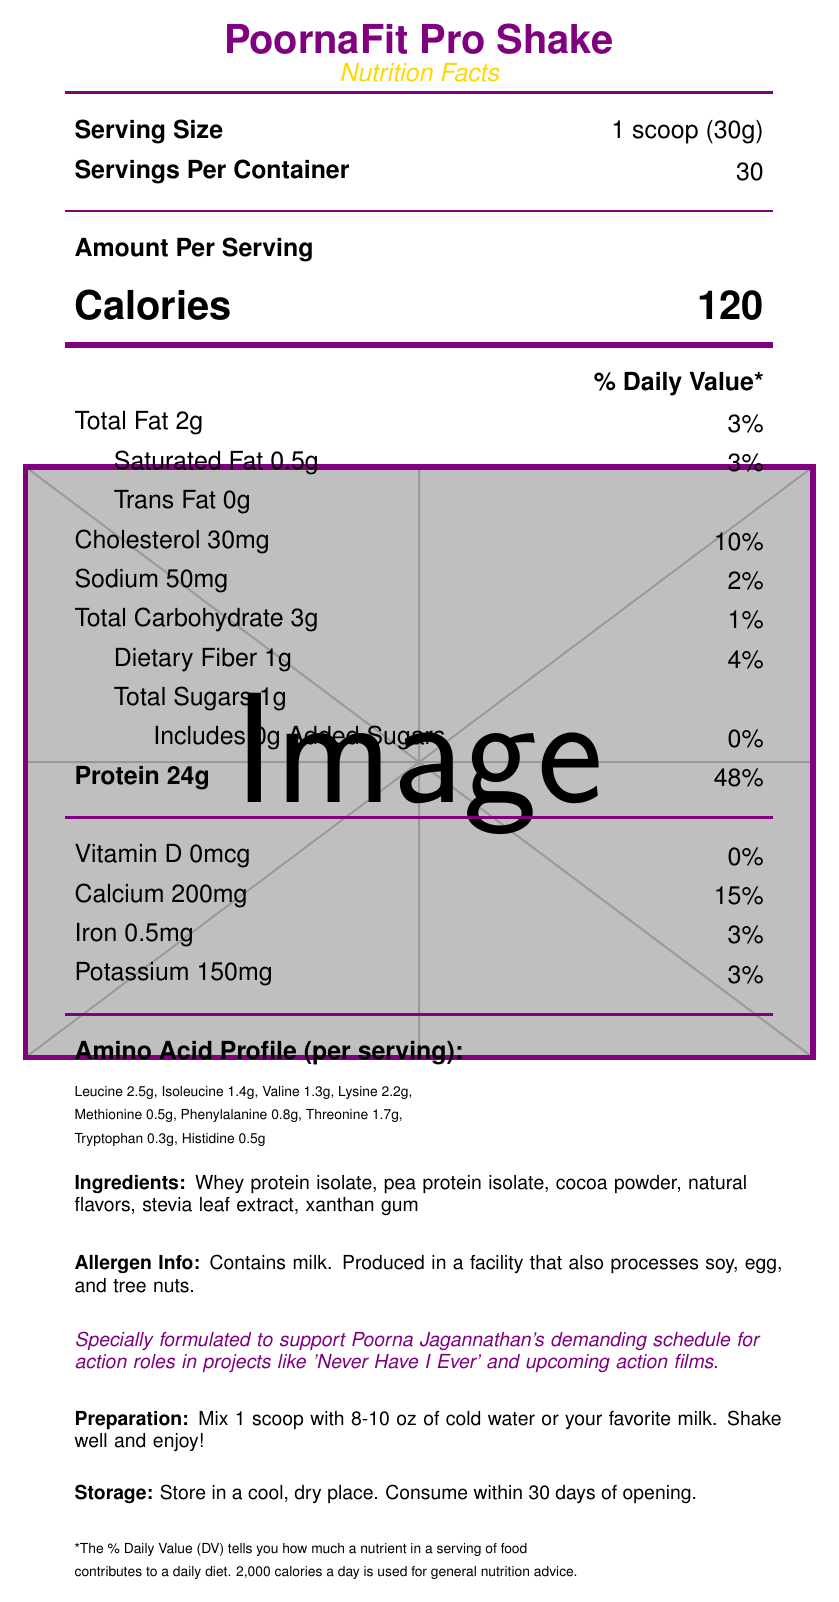what is the product name? The product name is explicitly mentioned at the top of the document.
Answer: PoornaFit Pro Shake what is the serving size? The serving size is listed near the top of the document.
Answer: 1 scoop (30g) how many servings are in the container? The number of servings per container is provided near the top of the document.
Answer: 30 how many grams of protein are in one serving? The amount of protein per serving is clearly stated in the document.
Answer: 24g what amount of leucine is in each serving? Leucine is included in the amino acid profile section of the document.
Answer: 2.5g what is the daily value percentage for calcium? The daily value percentage for calcium is given in the vitamins and minerals section.
Answer: 15% how many grams of dietary fiber are present? Dietary fiber content is indicated in the carbohydrate section.
Answer: 1g which ingredients are used in the protein shake? A. Whey protein isolate, cocoa powder B. Pea protein isolate, cocoa powder, sugar C. Stevia leaf extract, natural flavors, whey protein concentrate D. Whey protein isolate, pea protein isolate, xanthan gum Ingredients are listed as whey protein isolate, pea protein isolate, cocoa powder, natural flavors, stevia leaf extract, and xanthan gum.
Answer: D what amount of total fat does one serving contain? The total fat content per serving is provided in the nutritional information section.
Answer: 2g what is the total carbohydrate amount per serving? The total carbohydrates per serving are mentioned in the nutrition facts.
Answer: 3g is there any trans fat in the product? The amount of trans fat is listed as 0g.
Answer: No is there any added sugar in the protein shake? The amount of added sugars is 0g, as indicated in the document.
Answer: No which of the following amino acids has the highest amount per serving? A. Isoleucine B. Lysine C. Threonine D. Phenylalanine Lysine content per serving is 2.2g, which is higher than isoleucine (1.4g), threonine (1.7g), and phenylalanine (0.8g).
Answer: B. Lysine what does the product aim to support? The note on the document specifies support for Poorna Jagannathan's demanding schedule for action roles in projects like 'Never Have I Ever'.
Answer: Poorna Jagannathan's demanding schedule for action roles how should the protein shake be prepared? The preparation instructions are clearly outlined in the document.
Answer: Mix 1 scoop with 8-10 oz of cold water or milk what is the sodium content per serving? The sodium content per serving is found in the nutrition facts.
Answer: 50mg how many milligrams of cholesterol are in one serving? The cholesterol content per serving is provided in the nutritional information.
Answer: 30mg what is the total number of calories per serving? The number of calories per serving is displayed prominently in the nutritional section.
Answer: 120 does this product contain egg as an allergen? The document only mentions that it contains milk and is produced in a facility that also processes soy, egg, and tree nuts. It does not specify if it contains egg as an ingredient.
Answer: Cannot be determined summarize the document. The document primarily focuses on presenting the nutritional information and benefits of the protein shake designed for Poorna Jagannathan, along with practical preparation and storage details.
Answer: The document provides the nutritional facts for PoornaFit Pro Shake, specifically designed to support Poorna Jagannathan's demanding schedule. It includes details about serving size, calories, macronutrients, vitamins, and minerals, along with an amino acid profile, ingredients, allergen information, preparation instructions, and storage guidelines. 